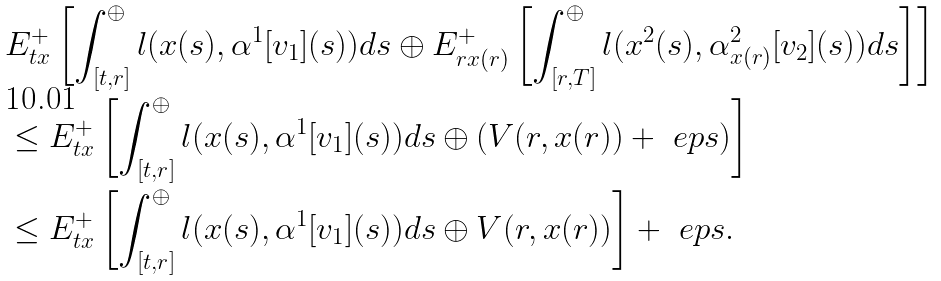Convert formula to latex. <formula><loc_0><loc_0><loc_500><loc_500>& E ^ { + } _ { t x } \left [ \int _ { [ t , r ] } ^ { \oplus } l ( x ( s ) , \alpha ^ { 1 } [ v _ { 1 } ] ( s ) ) d s \oplus E ^ { + } _ { r x ( r ) } \left [ \int _ { [ r , T ] } ^ { \oplus } l ( x ^ { 2 } ( s ) , \alpha ^ { 2 } _ { x ( r ) } [ v _ { 2 } ] ( s ) ) d s \right ] \right ] \\ & \leq E ^ { + } _ { t x } \left [ \int _ { [ t , r ] } ^ { \oplus } l ( x ( s ) , \alpha ^ { 1 } [ v _ { 1 } ] ( s ) ) d s \oplus ( V ( r , x ( r ) ) + \ e p s ) \right ] \\ & \leq E ^ { + } _ { t x } \left [ \int _ { [ t , r ] } ^ { \oplus } l ( x ( s ) , \alpha ^ { 1 } [ v _ { 1 } ] ( s ) ) d s \oplus V ( r , x ( r ) ) \right ] + \ e p s .</formula> 